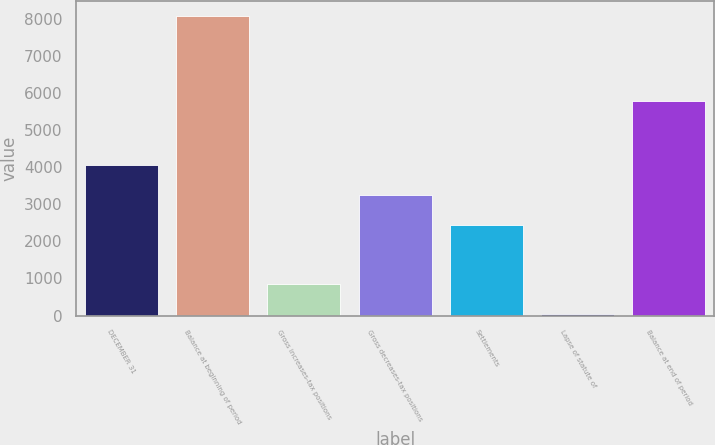Convert chart to OTSL. <chart><loc_0><loc_0><loc_500><loc_500><bar_chart><fcel>DECEMBER 31<fcel>Balance at beginning of period<fcel>Gross increases-tax positions<fcel>Gross decreases-tax positions<fcel>Settlements<fcel>Lapse of statute of<fcel>Balance at end of period<nl><fcel>4061.5<fcel>8088<fcel>840.3<fcel>3256.2<fcel>2450.9<fcel>35<fcel>5783<nl></chart> 